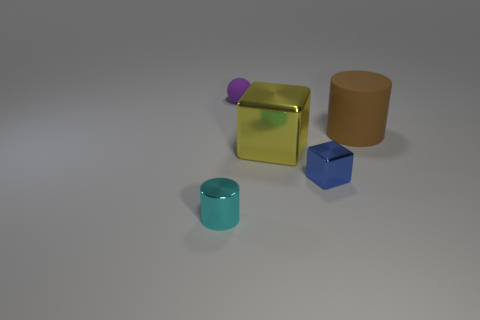What can you infer about the size relationships among the objects? Observing the size relationships, the large yellow cube is clearly the biggest object in the scene. The beige cylinder and the blue cube are both smaller, with the cylinder being taller but narrower and the blue cube having defined edges and faces. The purple sphere is quite small in comparison to these objects. Finally, the teal cylinder is the smallest item. The proportions and relative sizes help create a sense of depth and give an insight into the spatial configuration of this collection of objects. 